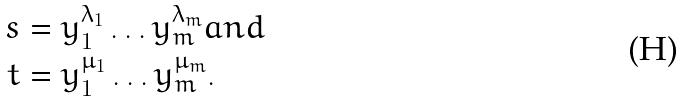Convert formula to latex. <formula><loc_0><loc_0><loc_500><loc_500>s & = y _ { 1 } ^ { \lambda _ { 1 } } \dots y _ { m } ^ { \lambda _ { m } } a n d \\ t & = y _ { 1 } ^ { \mu _ { 1 } } \dots y _ { m } ^ { \mu _ { m } } .</formula> 